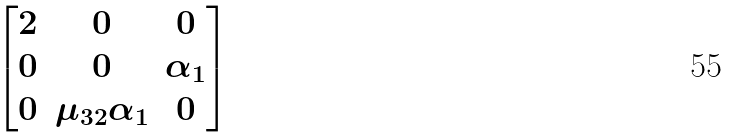Convert formula to latex. <formula><loc_0><loc_0><loc_500><loc_500>\begin{bmatrix} 2 & 0 & 0 \\ 0 & 0 & \alpha _ { 1 } \\ 0 & \mu _ { 3 2 } \alpha _ { 1 } & 0 \end{bmatrix}</formula> 